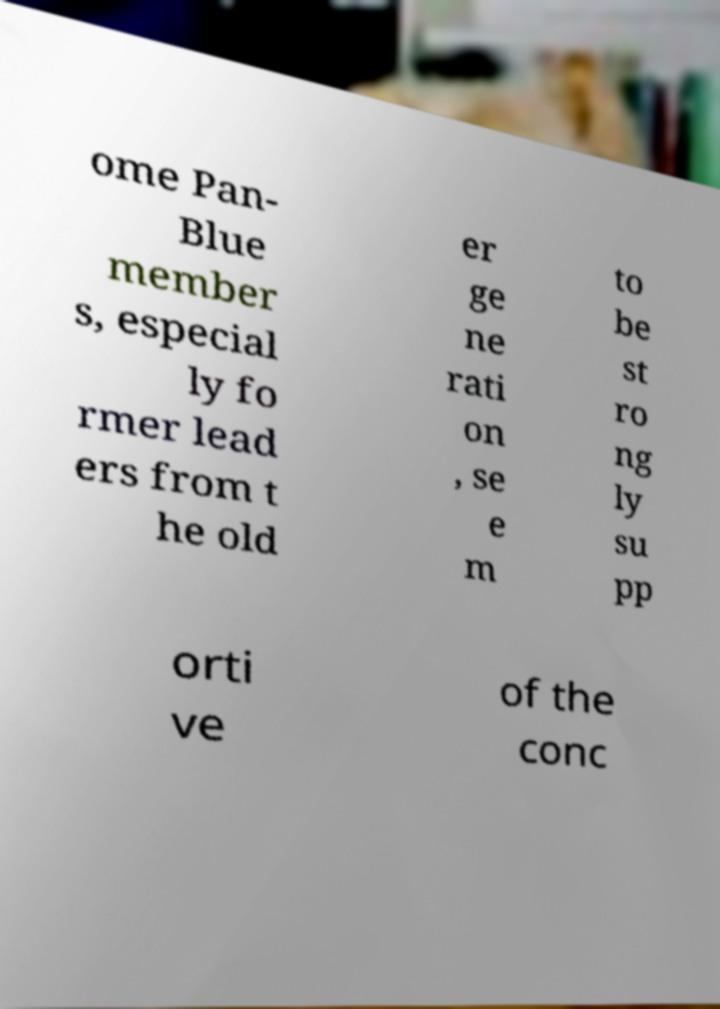Please identify and transcribe the text found in this image. ome Pan- Blue member s, especial ly fo rmer lead ers from t he old er ge ne rati on , se e m to be st ro ng ly su pp orti ve of the conc 